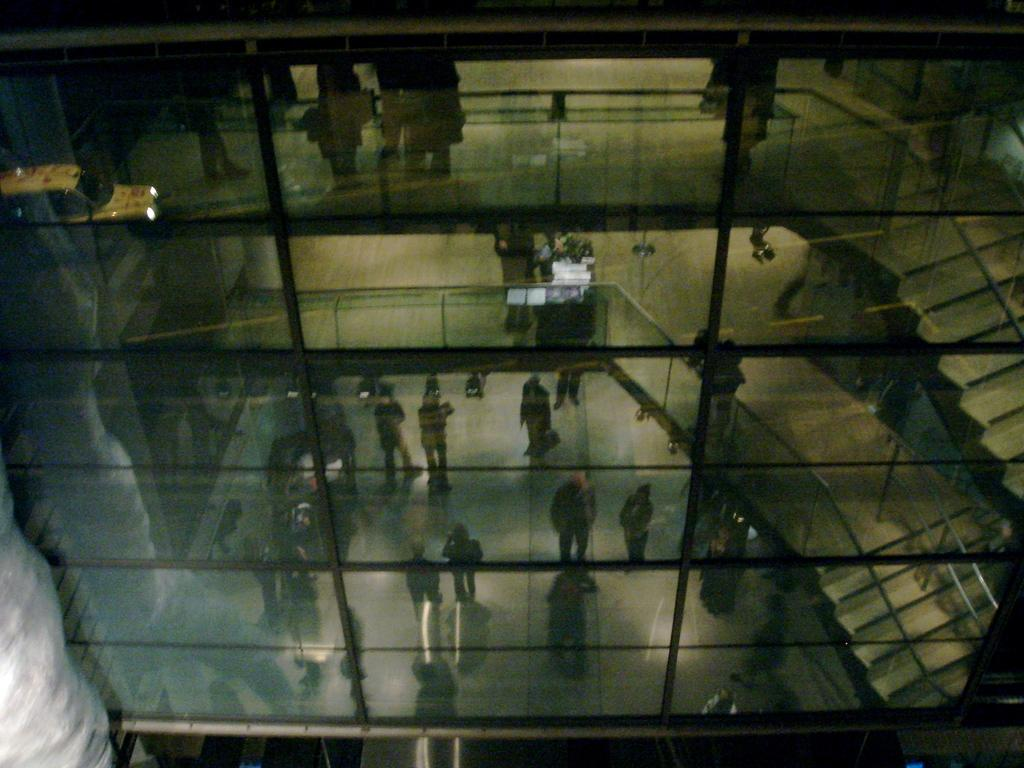What type of building is shown in the image? There is a glass building in the image. What can be seen inside the glass building? People and stairs are visible through the glass building. Are there any other structures visible through the glass building? Yes, fencing is visible through the glass building. Where is the toothbrush located in the image? There is no toothbrush present in the image. What type of legal advice is being given in the image? There is no lawyer or legal advice present in the image. 